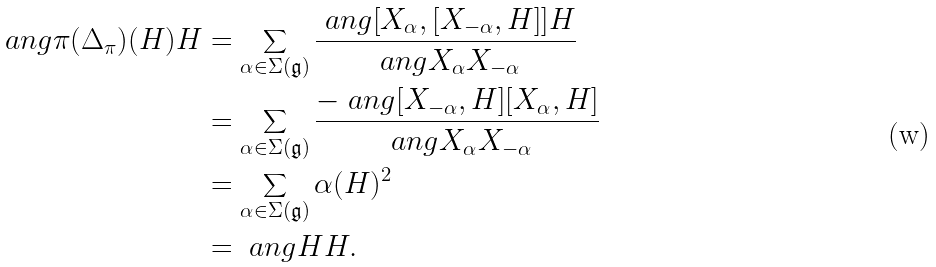Convert formula to latex. <formula><loc_0><loc_0><loc_500><loc_500>\ a n g { \pi ( \Delta _ { \pi } ) ( H ) } { H } & = \sum _ { \alpha \in \Sigma ( \mathfrak g ) } \frac { \ a n g { [ X _ { \alpha } , [ X _ { - \alpha } , H ] ] } H } { \ a n g { X _ { \alpha } } { X _ { - \alpha } } } \\ & = \sum _ { \alpha \in \Sigma ( \mathfrak g ) } \frac { - \ a n g { [ X _ { - \alpha } , H ] } { [ X _ { \alpha } , H ] } } { \ a n g { X _ { \alpha } } { X _ { - \alpha } } } \\ & = \sum _ { \alpha \in \Sigma ( \mathfrak g ) } \alpha ( H ) ^ { 2 } \\ & = \ a n g H H .</formula> 